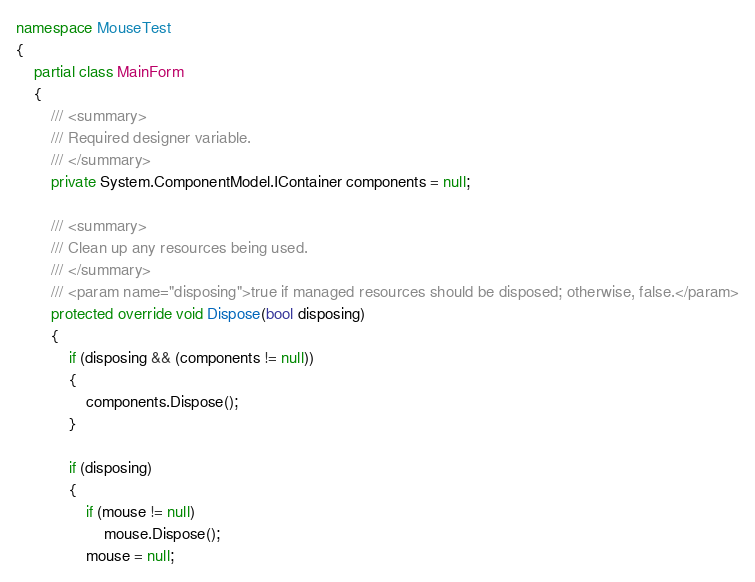Convert code to text. <code><loc_0><loc_0><loc_500><loc_500><_C#_>namespace MouseTest
{
    partial class MainForm
    {
        /// <summary>
        /// Required designer variable.
        /// </summary>
        private System.ComponentModel.IContainer components = null;

        /// <summary>
        /// Clean up any resources being used.
        /// </summary>
        /// <param name="disposing">true if managed resources should be disposed; otherwise, false.</param>
        protected override void Dispose(bool disposing)
        {
            if (disposing && (components != null))
            {
                components.Dispose();
            }

            if (disposing)
            {
                if (mouse != null)
                    mouse.Dispose();
                mouse = null;</code> 